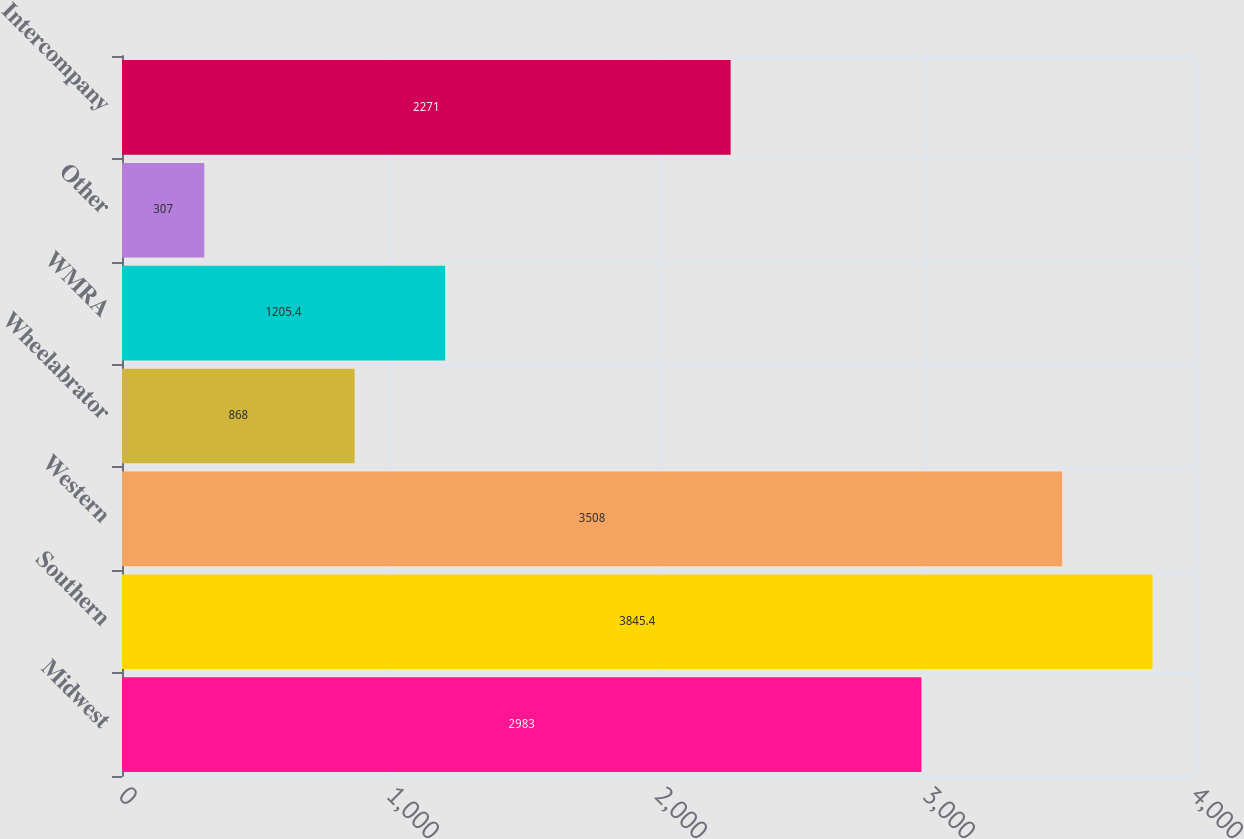<chart> <loc_0><loc_0><loc_500><loc_500><bar_chart><fcel>Midwest<fcel>Southern<fcel>Western<fcel>Wheelabrator<fcel>WMRA<fcel>Other<fcel>Intercompany<nl><fcel>2983<fcel>3845.4<fcel>3508<fcel>868<fcel>1205.4<fcel>307<fcel>2271<nl></chart> 